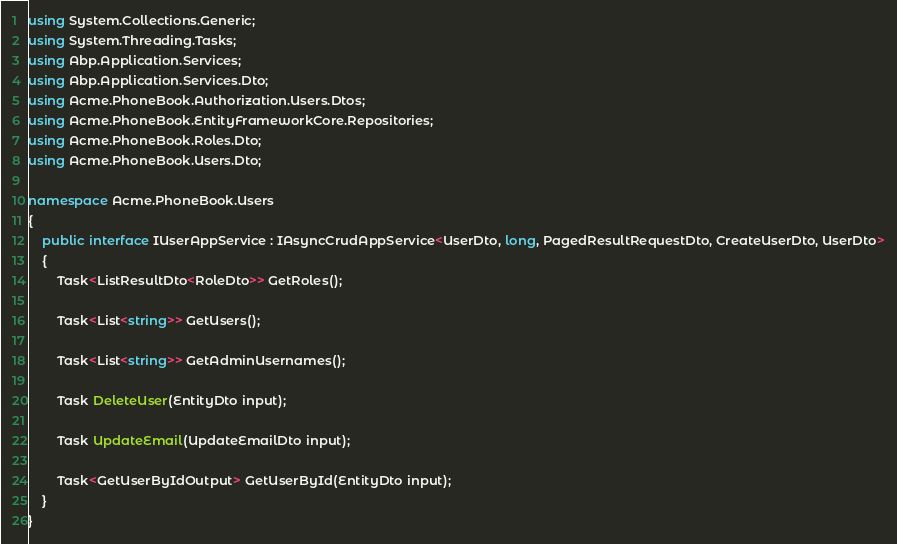Convert code to text. <code><loc_0><loc_0><loc_500><loc_500><_C#_>using System.Collections.Generic;
using System.Threading.Tasks;
using Abp.Application.Services;
using Abp.Application.Services.Dto;
using Acme.PhoneBook.Authorization.Users.Dtos;
using Acme.PhoneBook.EntityFrameworkCore.Repositories;
using Acme.PhoneBook.Roles.Dto;
using Acme.PhoneBook.Users.Dto;

namespace Acme.PhoneBook.Users
{
    public interface IUserAppService : IAsyncCrudAppService<UserDto, long, PagedResultRequestDto, CreateUserDto, UserDto>
    {
        Task<ListResultDto<RoleDto>> GetRoles();

        Task<List<string>> GetUsers();

        Task<List<string>> GetAdminUsernames();

        Task DeleteUser(EntityDto input);

        Task UpdateEmail(UpdateEmailDto input);

        Task<GetUserByIdOutput> GetUserById(EntityDto input);
    }
}</code> 